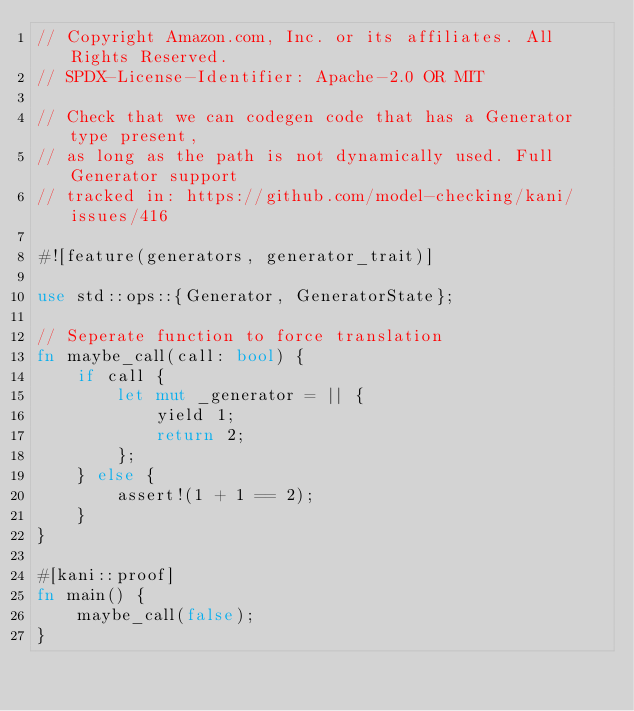<code> <loc_0><loc_0><loc_500><loc_500><_Rust_>// Copyright Amazon.com, Inc. or its affiliates. All Rights Reserved.
// SPDX-License-Identifier: Apache-2.0 OR MIT

// Check that we can codegen code that has a Generator type present,
// as long as the path is not dynamically used. Full Generator support
// tracked in: https://github.com/model-checking/kani/issues/416

#![feature(generators, generator_trait)]

use std::ops::{Generator, GeneratorState};

// Seperate function to force translation
fn maybe_call(call: bool) {
    if call {
        let mut _generator = || {
            yield 1;
            return 2;
        };
    } else {
        assert!(1 + 1 == 2);
    }
}

#[kani::proof]
fn main() {
    maybe_call(false);
}
</code> 